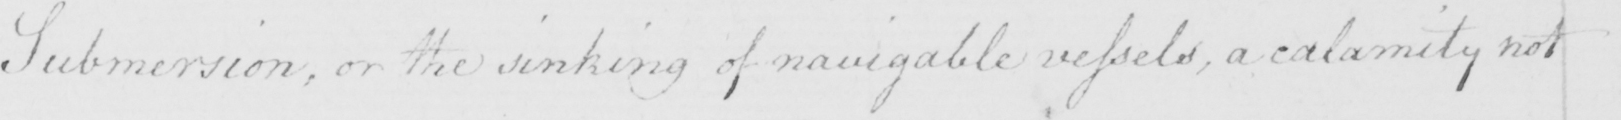What is written in this line of handwriting? Submersion , or the sinking of navigable vessels , a calamity not 